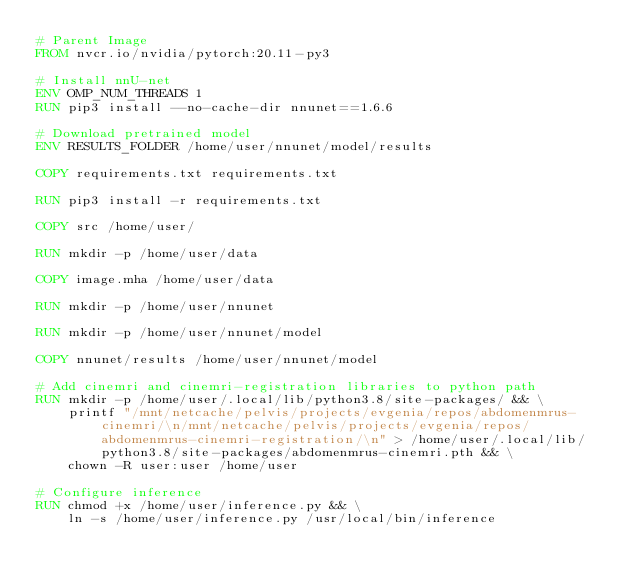<code> <loc_0><loc_0><loc_500><loc_500><_Dockerfile_># Parent Image
FROM nvcr.io/nvidia/pytorch:20.11-py3

# Install nnU-net
ENV OMP_NUM_THREADS 1
RUN pip3 install --no-cache-dir nnunet==1.6.6

# Download pretrained model
ENV RESULTS_FOLDER /home/user/nnunet/model/results

COPY requirements.txt requirements.txt

RUN pip3 install -r requirements.txt

COPY src /home/user/

RUN mkdir -p /home/user/data

COPY image.mha /home/user/data

RUN mkdir -p /home/user/nnunet

RUN mkdir -p /home/user/nnunet/model

COPY nnunet/results /home/user/nnunet/model

# Add cinemri and cinemri-registration libraries to python path
RUN mkdir -p /home/user/.local/lib/python3.8/site-packages/ && \
    printf "/mnt/netcache/pelvis/projects/evgenia/repos/abdomenmrus-cinemri/\n/mnt/netcache/pelvis/projects/evgenia/repos/abdomenmrus-cinemri-registration/\n" > /home/user/.local/lib/python3.8/site-packages/abdomenmrus-cinemri.pth && \
    chown -R user:user /home/user

# Configure inference
RUN chmod +x /home/user/inference.py && \
    ln -s /home/user/inference.py /usr/local/bin/inference
</code> 